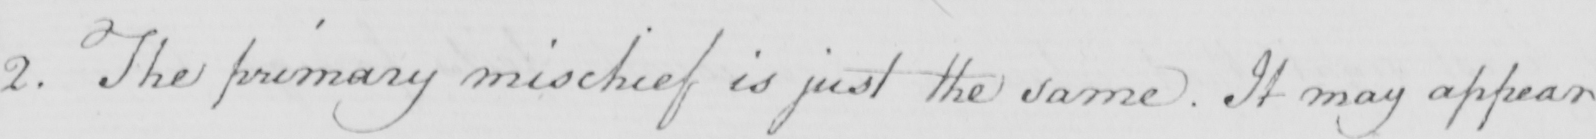Please transcribe the handwritten text in this image. 2 . The primary mischief is just the same . It may appear 